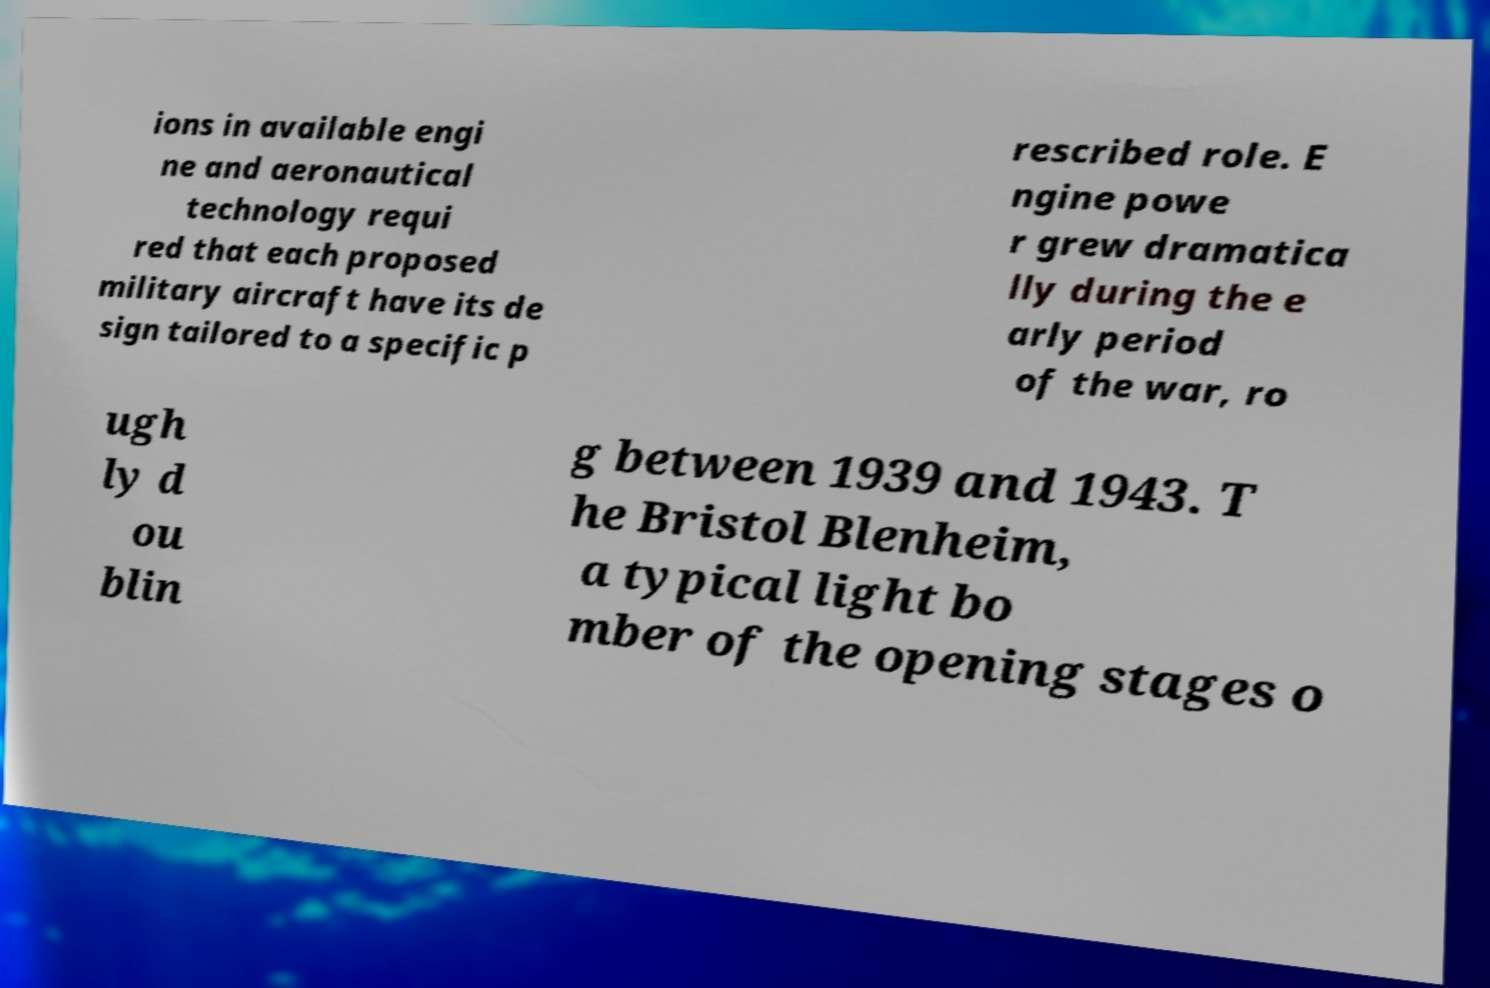There's text embedded in this image that I need extracted. Can you transcribe it verbatim? ions in available engi ne and aeronautical technology requi red that each proposed military aircraft have its de sign tailored to a specific p rescribed role. E ngine powe r grew dramatica lly during the e arly period of the war, ro ugh ly d ou blin g between 1939 and 1943. T he Bristol Blenheim, a typical light bo mber of the opening stages o 